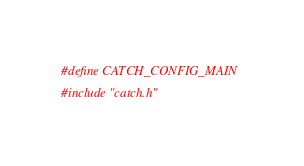<code> <loc_0><loc_0><loc_500><loc_500><_C++_>#define CATCH_CONFIG_MAIN
#include "catch.h"</code> 